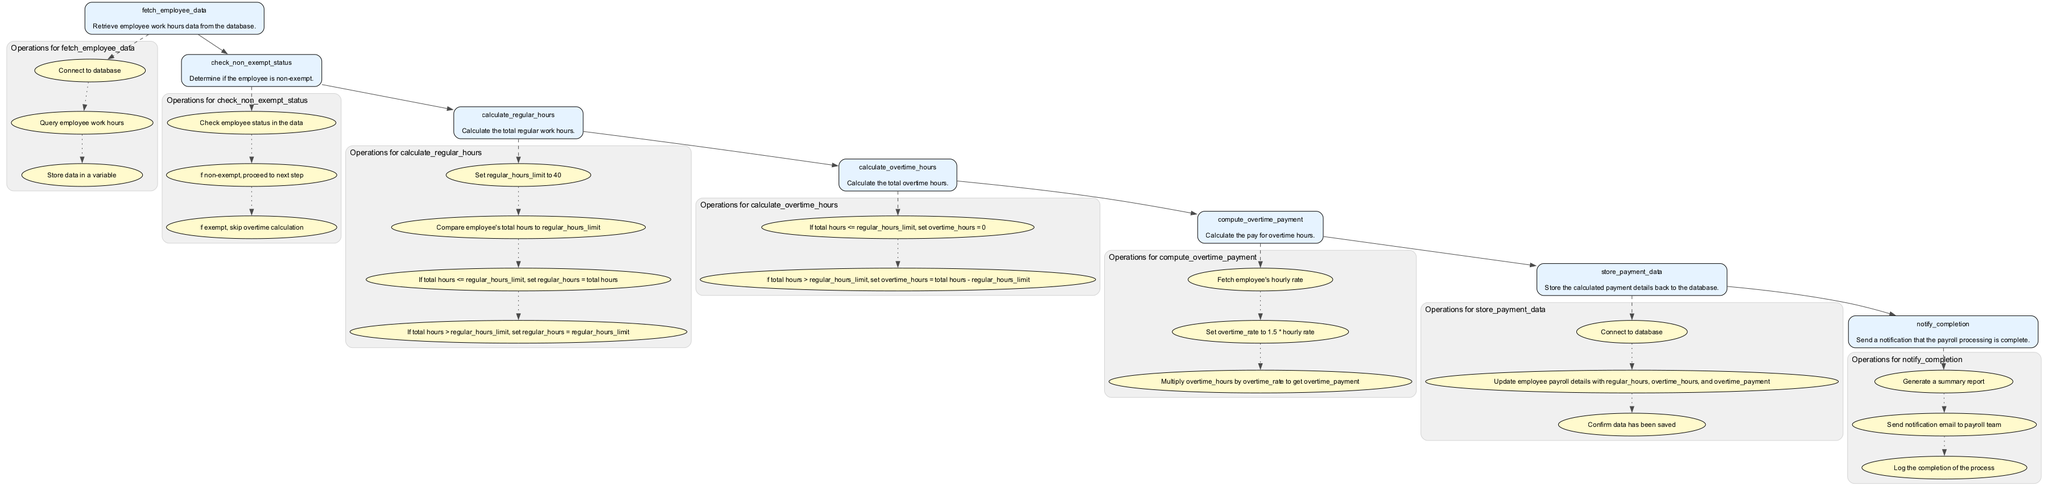What is the first step in the process? The diagram begins with the "fetch_employee_data" node, which indicates that this is the first operation taken to initiate the processing of overtime payments.
Answer: fetch employee data How many operations are listed under the "calculate_overtime_hours" process? The "calculate_overtime_hours" node details two operations, which are the checks and calculations related to overtime hours based on the total hours worked.
Answer: 2 What node follows "check_non_exempt_status"? After determining the non-exempt status of the employee, the next node in the flow is "calculate_regular_hours," indicating the continuation of the process if the employee is non-exempt.
Answer: calculate regular hours What does the "notify_completion" node do? The "notify_completion" node involves generating a report, sending a notification email to the payroll team, and logging the completion of the payroll processing, reflecting the final step of the workflow.
Answer: sends notification How many total nodes are in the diagram? The diagram consists of six main nodes representing distinct steps in the overtime payment processing function, excluding the operations subgraphs.
Answer: 6 What is the relationship between "calculate_regular_hours" and "calculate_overtime_hours"? "calculate_overtime_hours" directly follows "calculate_regular_hours," indicating that the calculation of overtime hours is contingent upon the regular hours calculated in the preceding step.
Answer: direct follow What is the overtime rate calculated based on? The overtime rate is set to 1.5 times the employee's hourly rate, which is linked to how the overtime payment is determined in the "compute_overtime_payment" step.
Answer: hourly rate If the total hours exceed the regular hours limit, what happens to the overtime hours? If the total hours exceed the regular hours limit, the overtime hours are calculated as the total hours minus the regular hours limit, indicating how much extra time is compensated.
Answer: total hours minus regular hours limit 